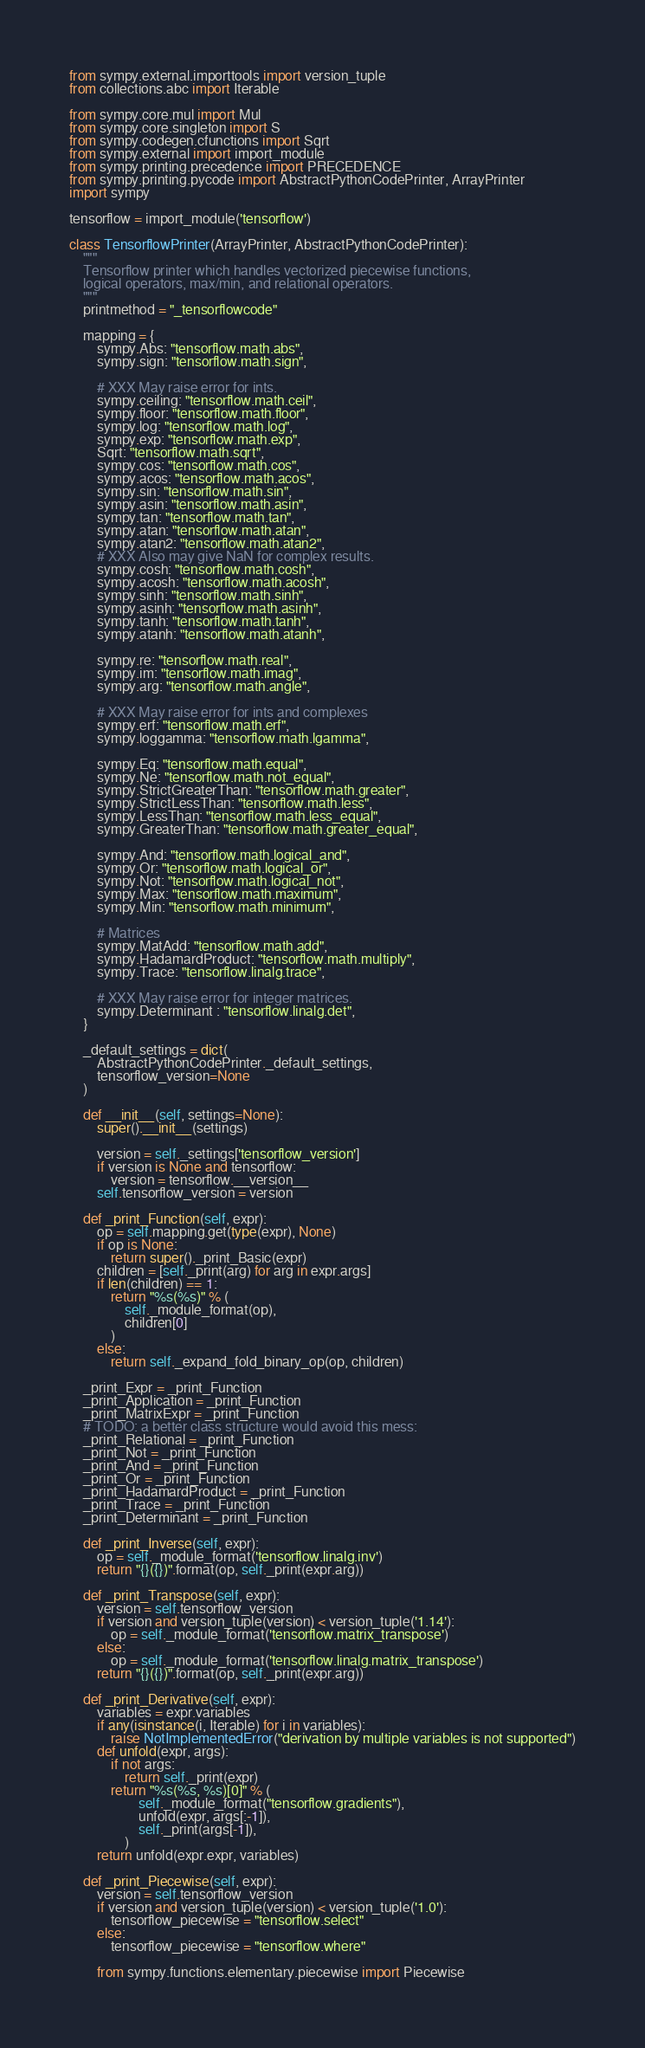<code> <loc_0><loc_0><loc_500><loc_500><_Python_>from sympy.external.importtools import version_tuple
from collections.abc import Iterable

from sympy.core.mul import Mul
from sympy.core.singleton import S
from sympy.codegen.cfunctions import Sqrt
from sympy.external import import_module
from sympy.printing.precedence import PRECEDENCE
from sympy.printing.pycode import AbstractPythonCodePrinter, ArrayPrinter
import sympy

tensorflow = import_module('tensorflow')

class TensorflowPrinter(ArrayPrinter, AbstractPythonCodePrinter):
    """
    Tensorflow printer which handles vectorized piecewise functions,
    logical operators, max/min, and relational operators.
    """
    printmethod = "_tensorflowcode"

    mapping = {
        sympy.Abs: "tensorflow.math.abs",
        sympy.sign: "tensorflow.math.sign",

        # XXX May raise error for ints.
        sympy.ceiling: "tensorflow.math.ceil",
        sympy.floor: "tensorflow.math.floor",
        sympy.log: "tensorflow.math.log",
        sympy.exp: "tensorflow.math.exp",
        Sqrt: "tensorflow.math.sqrt",
        sympy.cos: "tensorflow.math.cos",
        sympy.acos: "tensorflow.math.acos",
        sympy.sin: "tensorflow.math.sin",
        sympy.asin: "tensorflow.math.asin",
        sympy.tan: "tensorflow.math.tan",
        sympy.atan: "tensorflow.math.atan",
        sympy.atan2: "tensorflow.math.atan2",
        # XXX Also may give NaN for complex results.
        sympy.cosh: "tensorflow.math.cosh",
        sympy.acosh: "tensorflow.math.acosh",
        sympy.sinh: "tensorflow.math.sinh",
        sympy.asinh: "tensorflow.math.asinh",
        sympy.tanh: "tensorflow.math.tanh",
        sympy.atanh: "tensorflow.math.atanh",

        sympy.re: "tensorflow.math.real",
        sympy.im: "tensorflow.math.imag",
        sympy.arg: "tensorflow.math.angle",

        # XXX May raise error for ints and complexes
        sympy.erf: "tensorflow.math.erf",
        sympy.loggamma: "tensorflow.math.lgamma",

        sympy.Eq: "tensorflow.math.equal",
        sympy.Ne: "tensorflow.math.not_equal",
        sympy.StrictGreaterThan: "tensorflow.math.greater",
        sympy.StrictLessThan: "tensorflow.math.less",
        sympy.LessThan: "tensorflow.math.less_equal",
        sympy.GreaterThan: "tensorflow.math.greater_equal",

        sympy.And: "tensorflow.math.logical_and",
        sympy.Or: "tensorflow.math.logical_or",
        sympy.Not: "tensorflow.math.logical_not",
        sympy.Max: "tensorflow.math.maximum",
        sympy.Min: "tensorflow.math.minimum",

        # Matrices
        sympy.MatAdd: "tensorflow.math.add",
        sympy.HadamardProduct: "tensorflow.math.multiply",
        sympy.Trace: "tensorflow.linalg.trace",

        # XXX May raise error for integer matrices.
        sympy.Determinant : "tensorflow.linalg.det",
    }

    _default_settings = dict(
        AbstractPythonCodePrinter._default_settings,
        tensorflow_version=None
    )

    def __init__(self, settings=None):
        super().__init__(settings)

        version = self._settings['tensorflow_version']
        if version is None and tensorflow:
            version = tensorflow.__version__
        self.tensorflow_version = version

    def _print_Function(self, expr):
        op = self.mapping.get(type(expr), None)
        if op is None:
            return super()._print_Basic(expr)
        children = [self._print(arg) for arg in expr.args]
        if len(children) == 1:
            return "%s(%s)" % (
                self._module_format(op),
                children[0]
            )
        else:
            return self._expand_fold_binary_op(op, children)

    _print_Expr = _print_Function
    _print_Application = _print_Function
    _print_MatrixExpr = _print_Function
    # TODO: a better class structure would avoid this mess:
    _print_Relational = _print_Function
    _print_Not = _print_Function
    _print_And = _print_Function
    _print_Or = _print_Function
    _print_HadamardProduct = _print_Function
    _print_Trace = _print_Function
    _print_Determinant = _print_Function

    def _print_Inverse(self, expr):
        op = self._module_format('tensorflow.linalg.inv')
        return "{}({})".format(op, self._print(expr.arg))

    def _print_Transpose(self, expr):
        version = self.tensorflow_version
        if version and version_tuple(version) < version_tuple('1.14'):
            op = self._module_format('tensorflow.matrix_transpose')
        else:
            op = self._module_format('tensorflow.linalg.matrix_transpose')
        return "{}({})".format(op, self._print(expr.arg))

    def _print_Derivative(self, expr):
        variables = expr.variables
        if any(isinstance(i, Iterable) for i in variables):
            raise NotImplementedError("derivation by multiple variables is not supported")
        def unfold(expr, args):
            if not args:
                return self._print(expr)
            return "%s(%s, %s)[0]" % (
                    self._module_format("tensorflow.gradients"),
                    unfold(expr, args[:-1]),
                    self._print(args[-1]),
                )
        return unfold(expr.expr, variables)

    def _print_Piecewise(self, expr):
        version = self.tensorflow_version
        if version and version_tuple(version) < version_tuple('1.0'):
            tensorflow_piecewise = "tensorflow.select"
        else:
            tensorflow_piecewise = "tensorflow.where"

        from sympy.functions.elementary.piecewise import Piecewise</code> 